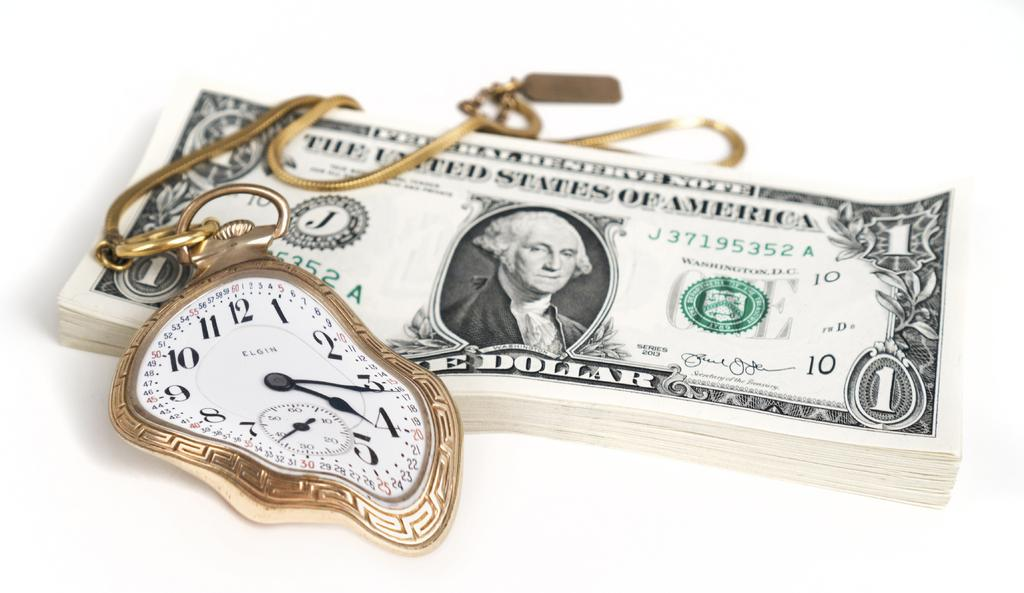What is the main subject of the image? The main subject of the image is a bundle of dollar notes. Are there any other objects or accessories visible in the image? Yes, there is a clock chain in the image. What is the color of the surface on which the objects are placed? The surface is white. What type of reaction can be seen from the sticks in the image? There are no sticks present in the image, so it is not possible to observe any reaction from them. 